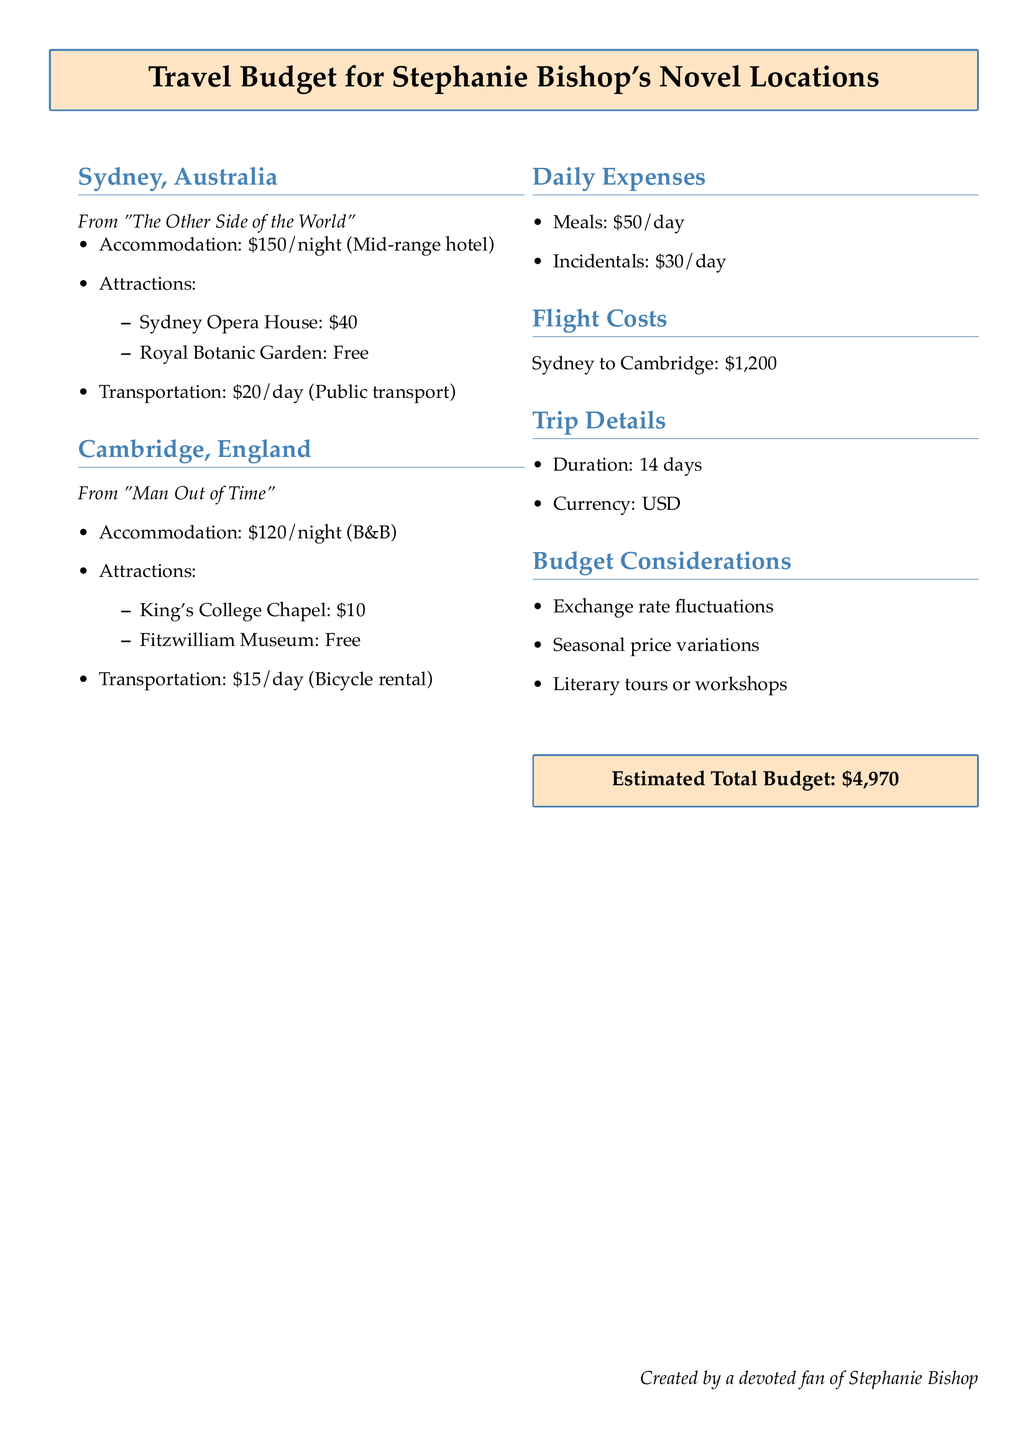What is the accommodation cost per night in Sydney? The accommodation cost per night in Sydney is \$150, as indicated in the document.
Answer: \$150 What attractions are listed for Cambridge? The attractions listed for Cambridge are King's College Chapel and Fitzwilliam Museum, mentioned under the corresponding section.
Answer: King's College Chapel, Fitzwilliam Museum What is the daily transportation cost in Sydney? The daily transportation cost in Sydney is \$20, as specified in the travel budget.
Answer: \$20 How much will meals cost per day during the trip? The document states that meals will cost \$50 per day during the trip.
Answer: \$50 What is the total estimated budget for the trip? The total estimated budget for the trip is provided at the end of the document as \$4,970.
Answer: \$4,970 How many days is the trip planned for? The trip duration is specified as 14 days within the document.
Answer: 14 days What is the flight cost from Sydney to Cambridge? The flight cost from Sydney to Cambridge is stated as \$1,200 in the flight costs section.
Answer: \$1,200 What budget considerations are mentioned? The budget considerations include exchange rate fluctuations, seasonal price variations, and literary tours or workshops, as noted in the document.
Answer: Exchange rate fluctuations, seasonal price variations, literary tours or workshops What type of accommodation is recommended in Cambridge? The type of accommodation recommended in Cambridge is a B&B, mentioned in the Cambridge section.
Answer: B&B 